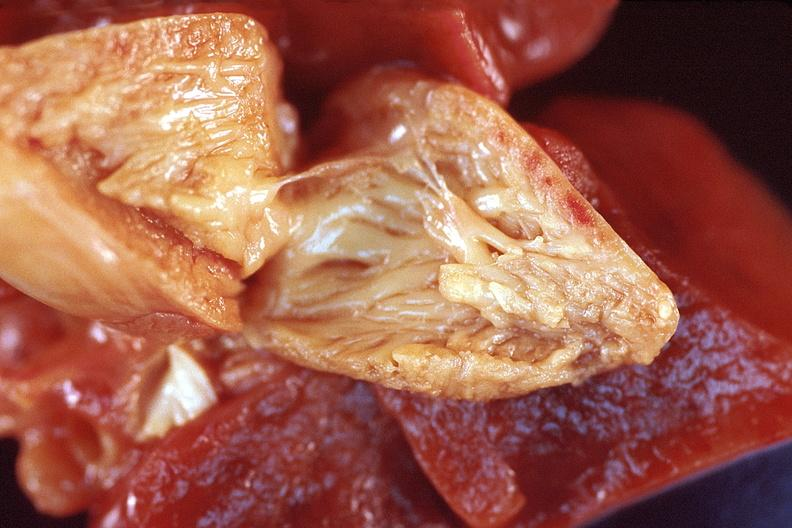what does this image show?
Answer the question using a single word or phrase. Heart 